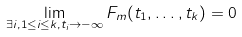Convert formula to latex. <formula><loc_0><loc_0><loc_500><loc_500>\lim _ { \exists i , 1 \leq i \leq k , t _ { i } \rightarrow - \infty } F _ { m } ( t _ { 1 } , \dots , t _ { k } ) = 0</formula> 